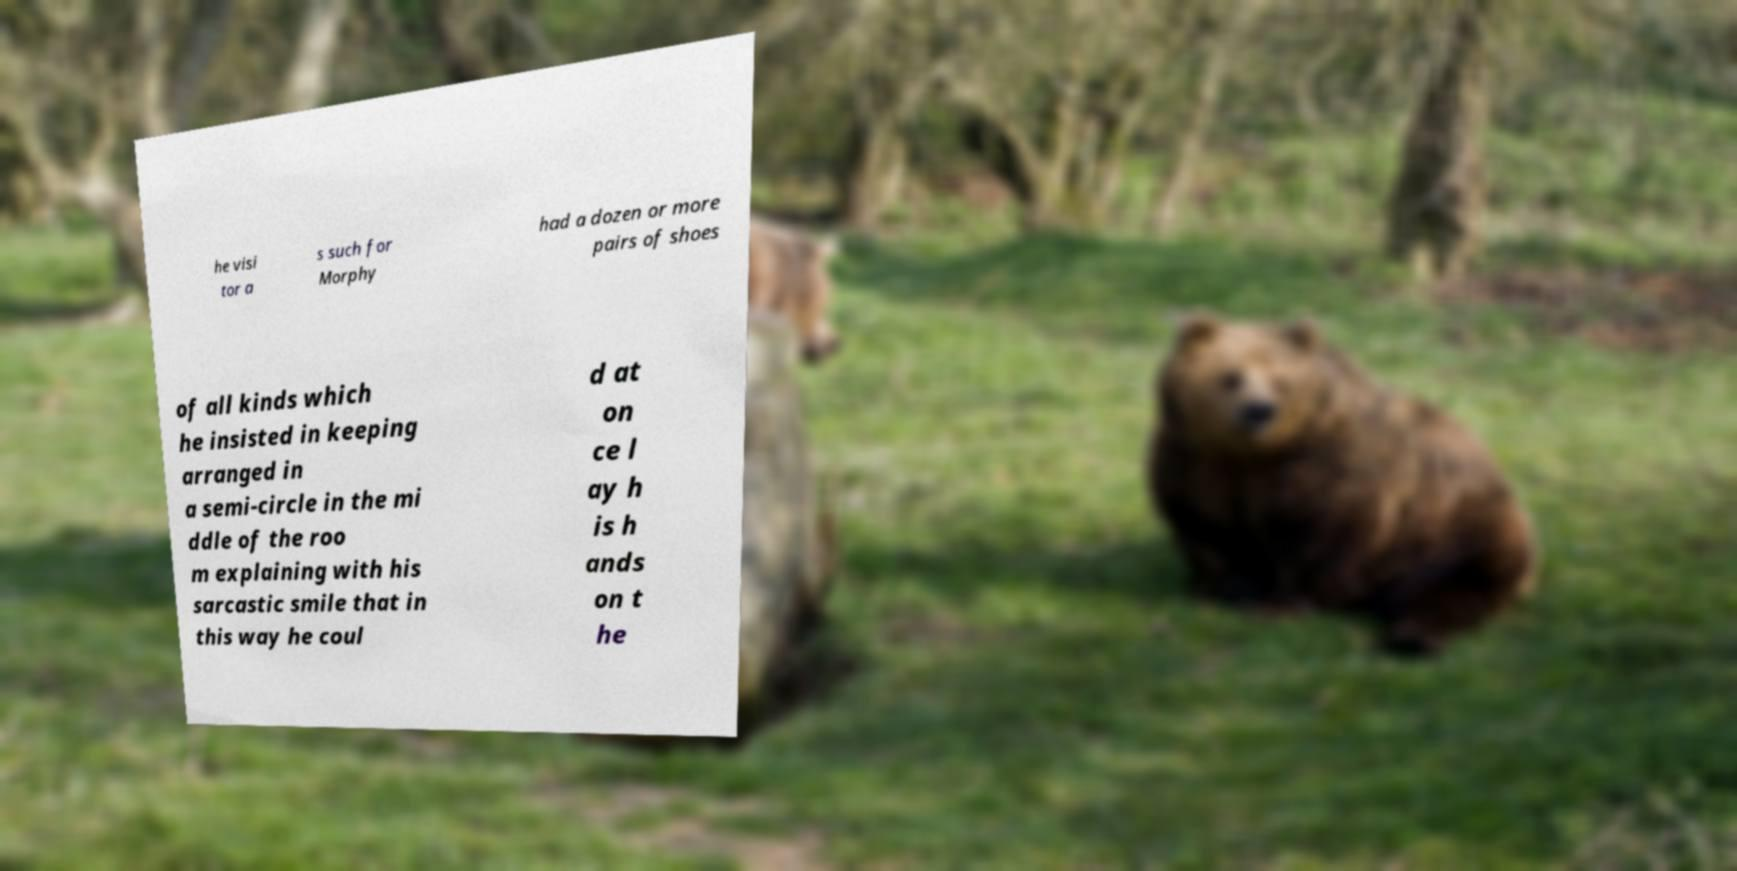I need the written content from this picture converted into text. Can you do that? he visi tor a s such for Morphy had a dozen or more pairs of shoes of all kinds which he insisted in keeping arranged in a semi-circle in the mi ddle of the roo m explaining with his sarcastic smile that in this way he coul d at on ce l ay h is h ands on t he 